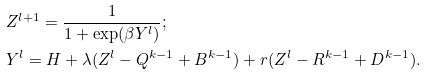Convert formula to latex. <formula><loc_0><loc_0><loc_500><loc_500>& Z ^ { l + 1 } = \frac { 1 } { 1 + \exp ( \beta Y ^ { l } ) } ; \\ & Y ^ { l } = H + \lambda ( Z ^ { l } - Q ^ { k - 1 } + B ^ { k - 1 } ) + r ( Z ^ { l } - R ^ { k - 1 } + D ^ { k - 1 } ) .</formula> 